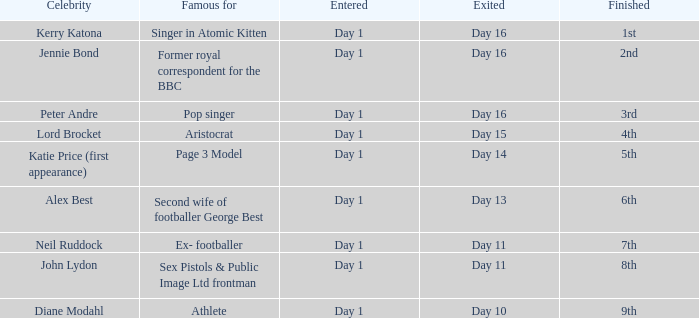Name the finished for exited of day 13 6th. 